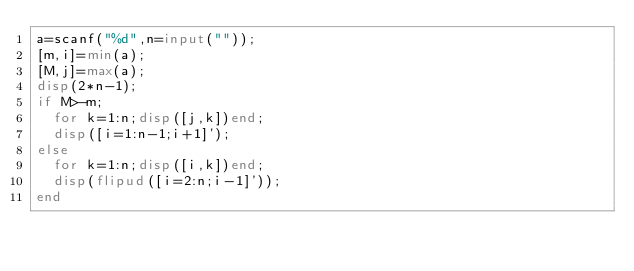Convert code to text. <code><loc_0><loc_0><loc_500><loc_500><_Octave_>a=scanf("%d",n=input(""));
[m,i]=min(a);
[M,j]=max(a);
disp(2*n-1);
if M>-m;
	for k=1:n;disp([j,k])end;
	disp([i=1:n-1;i+1]');
else
	for k=1:n;disp([i,k])end;
	disp(flipud([i=2:n;i-1]'));
end</code> 